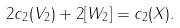<formula> <loc_0><loc_0><loc_500><loc_500>2 c _ { 2 } ( V _ { 2 } ) + 2 [ W _ { 2 } ] = c _ { 2 } ( X ) .</formula> 